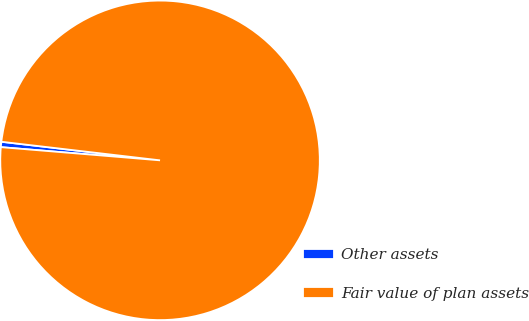Convert chart. <chart><loc_0><loc_0><loc_500><loc_500><pie_chart><fcel>Other assets<fcel>Fair value of plan assets<nl><fcel>0.54%<fcel>99.46%<nl></chart> 